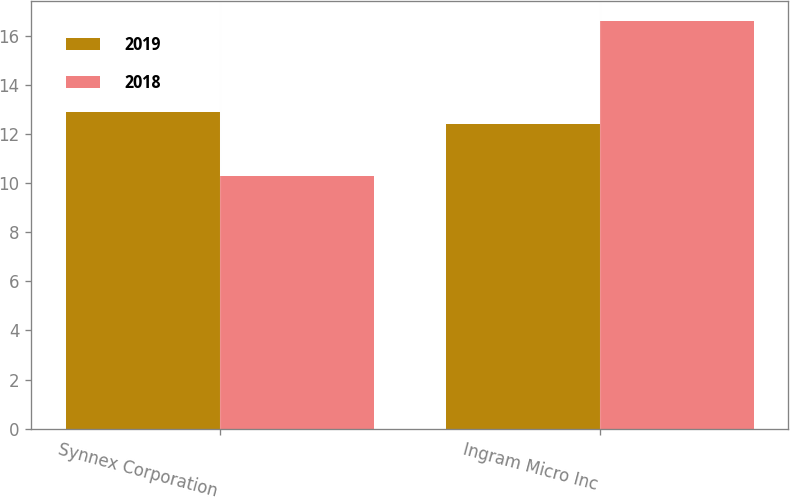<chart> <loc_0><loc_0><loc_500><loc_500><stacked_bar_chart><ecel><fcel>Synnex Corporation<fcel>Ingram Micro Inc<nl><fcel>2019<fcel>12.9<fcel>12.4<nl><fcel>2018<fcel>10.3<fcel>16.6<nl></chart> 